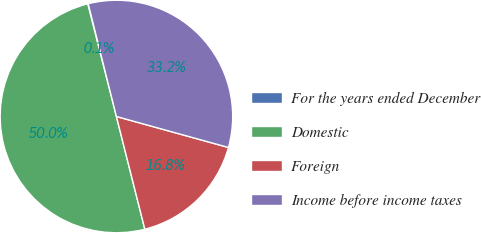Convert chart to OTSL. <chart><loc_0><loc_0><loc_500><loc_500><pie_chart><fcel>For the years ended December<fcel>Domestic<fcel>Foreign<fcel>Income before income taxes<nl><fcel>0.07%<fcel>49.96%<fcel>16.77%<fcel>33.19%<nl></chart> 